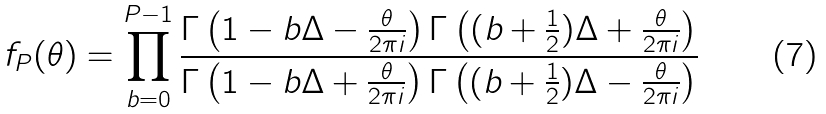<formula> <loc_0><loc_0><loc_500><loc_500>f _ { P } ( \theta ) = \prod _ { b = 0 } ^ { P - 1 } \frac { \Gamma \left ( 1 - b \Delta - \frac { \theta } { 2 \pi i } \right ) \Gamma \left ( ( b + \frac { 1 } { 2 } ) \Delta + \frac { \theta } { 2 \pi i } \right ) } { \Gamma \left ( 1 - b \Delta + \frac { \theta } { 2 \pi i } \right ) \Gamma \left ( ( b + \frac { 1 } { 2 } ) \Delta - \frac { \theta } { 2 \pi i } \right ) }</formula> 